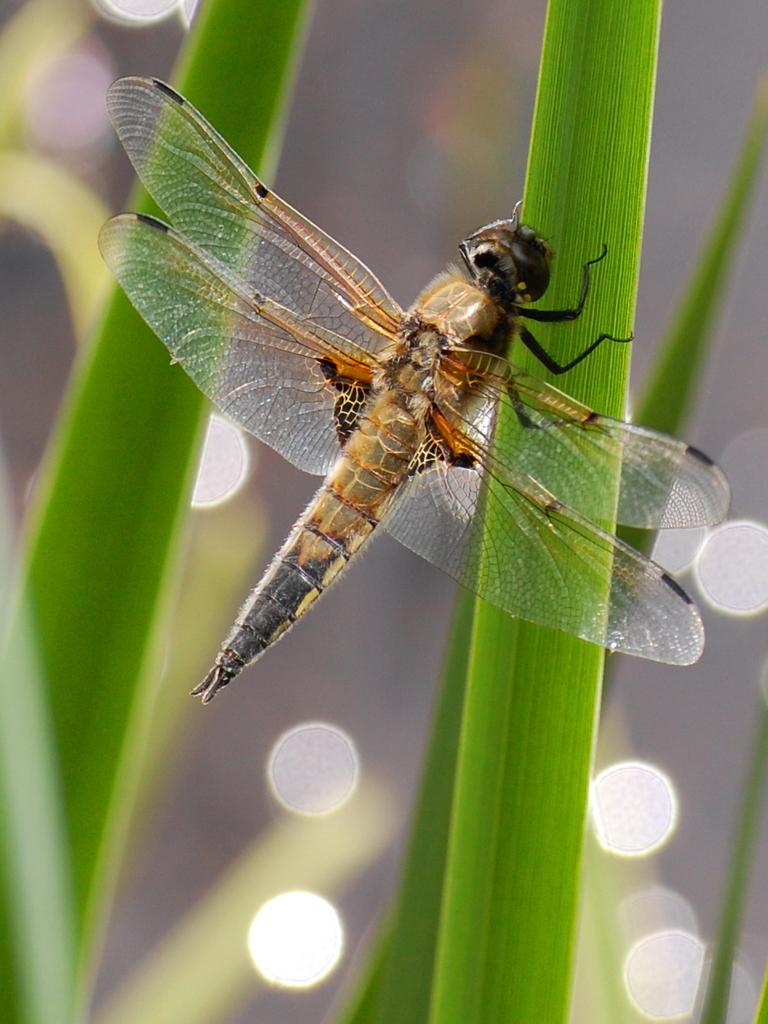What type of insect is in the image? There is a grasshopper in the image. What is the grasshopper standing on? The grasshopper is standing on a plant. Is there any confusion about the type of insect in the image? Yes, the grasshopper appears to be a dragonfly. What type of seed is visible in the image? There is no seed present in the image. What is the limit of the grasshopper's movement in the image? The grasshopper's movement is not limited in the image; it is standing on a plant. Is there a train visible in the image? There is no train present in the image. 